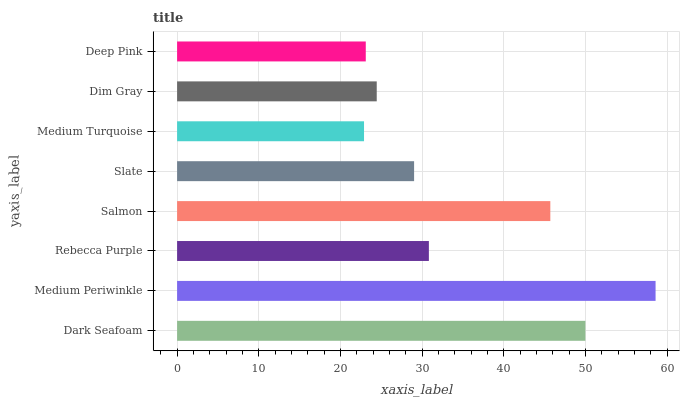Is Medium Turquoise the minimum?
Answer yes or no. Yes. Is Medium Periwinkle the maximum?
Answer yes or no. Yes. Is Rebecca Purple the minimum?
Answer yes or no. No. Is Rebecca Purple the maximum?
Answer yes or no. No. Is Medium Periwinkle greater than Rebecca Purple?
Answer yes or no. Yes. Is Rebecca Purple less than Medium Periwinkle?
Answer yes or no. Yes. Is Rebecca Purple greater than Medium Periwinkle?
Answer yes or no. No. Is Medium Periwinkle less than Rebecca Purple?
Answer yes or no. No. Is Rebecca Purple the high median?
Answer yes or no. Yes. Is Slate the low median?
Answer yes or no. Yes. Is Deep Pink the high median?
Answer yes or no. No. Is Rebecca Purple the low median?
Answer yes or no. No. 